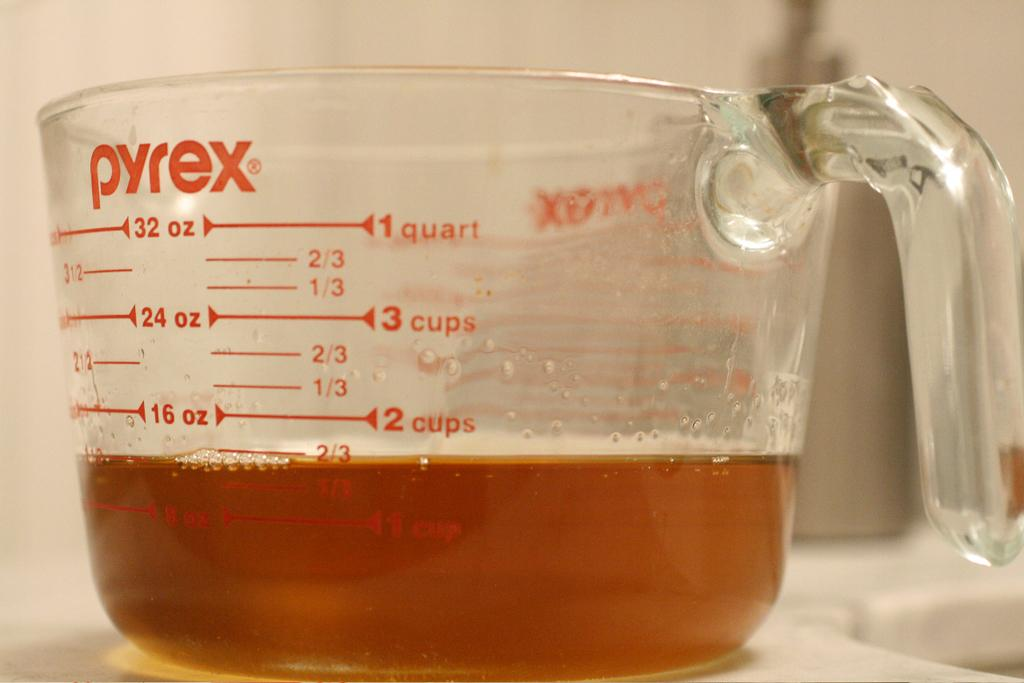<image>
Create a compact narrative representing the image presented. A Pyrex measuring cup with about 1/2 a cup of brown liquid in it. 